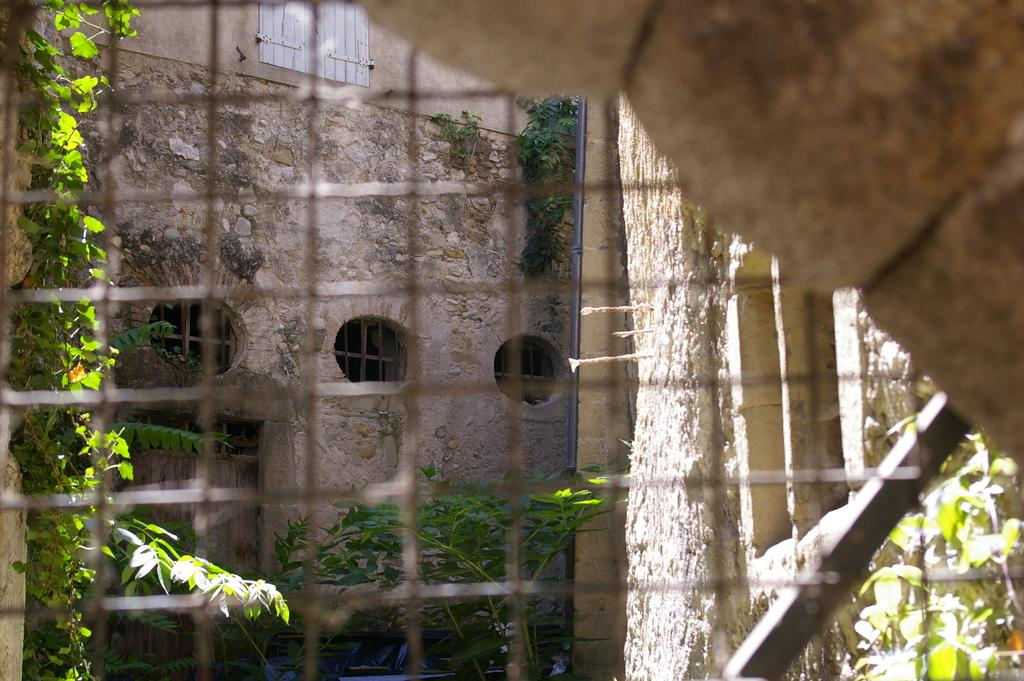What type of material is featured in the image? The image contains a welded mesh wire. What can be seen on the right side at the top corner of the image? There is a wall visible on the right side at the top corner. What is visible in the background of the image? In the background, there are walls, windows, plants, a door, and a pole. What type of vegetable is being chopped on the table in the image? There is no table or vegetable present in the image; it features a welded mesh wire and various elements in the background. 